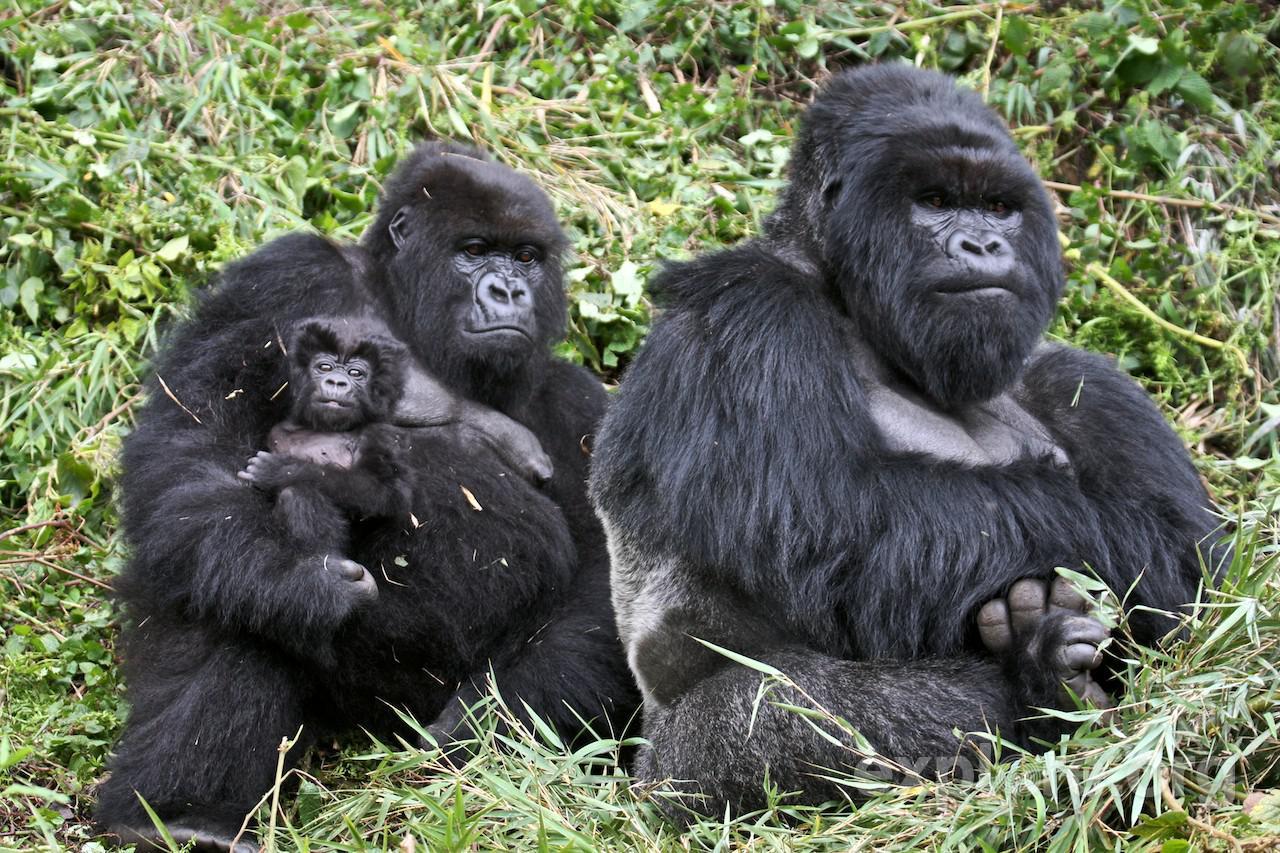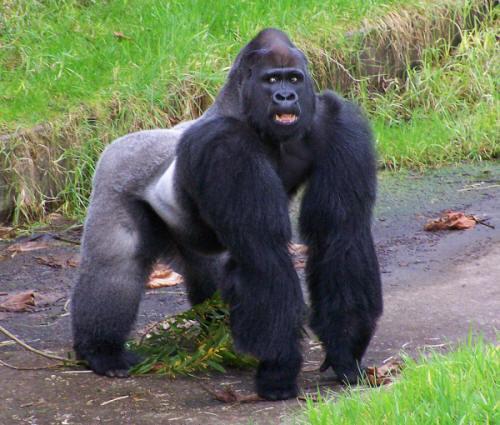The first image is the image on the left, the second image is the image on the right. For the images shown, is this caption "A baby gorilla is with at least one adult in one image." true? Answer yes or no. Yes. 